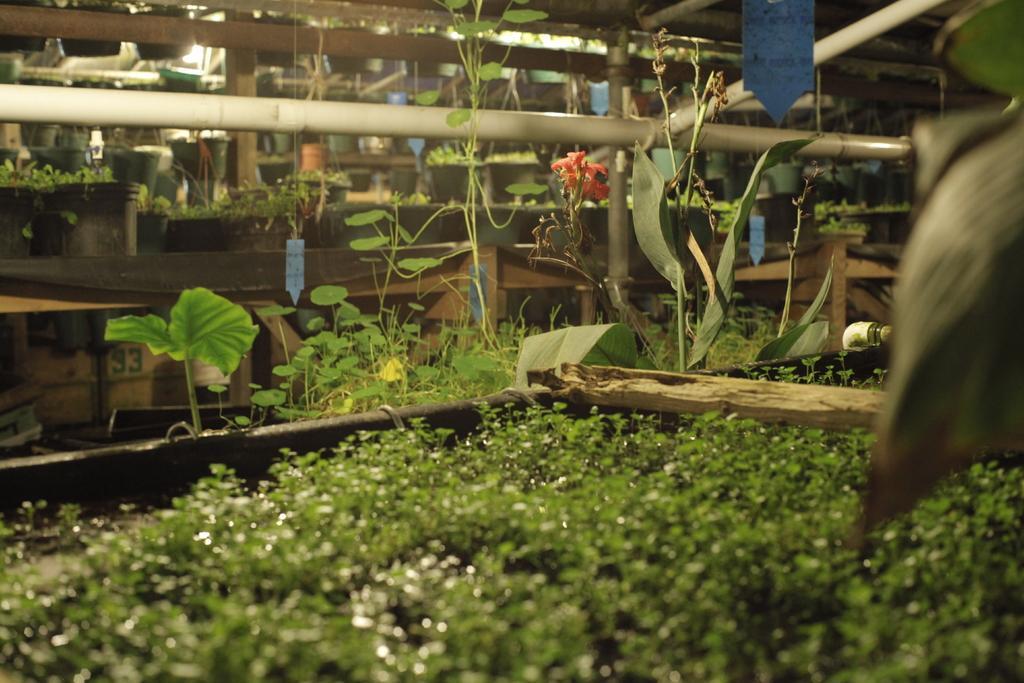Please provide a concise description of this image. This picture shows few plants few pots. 